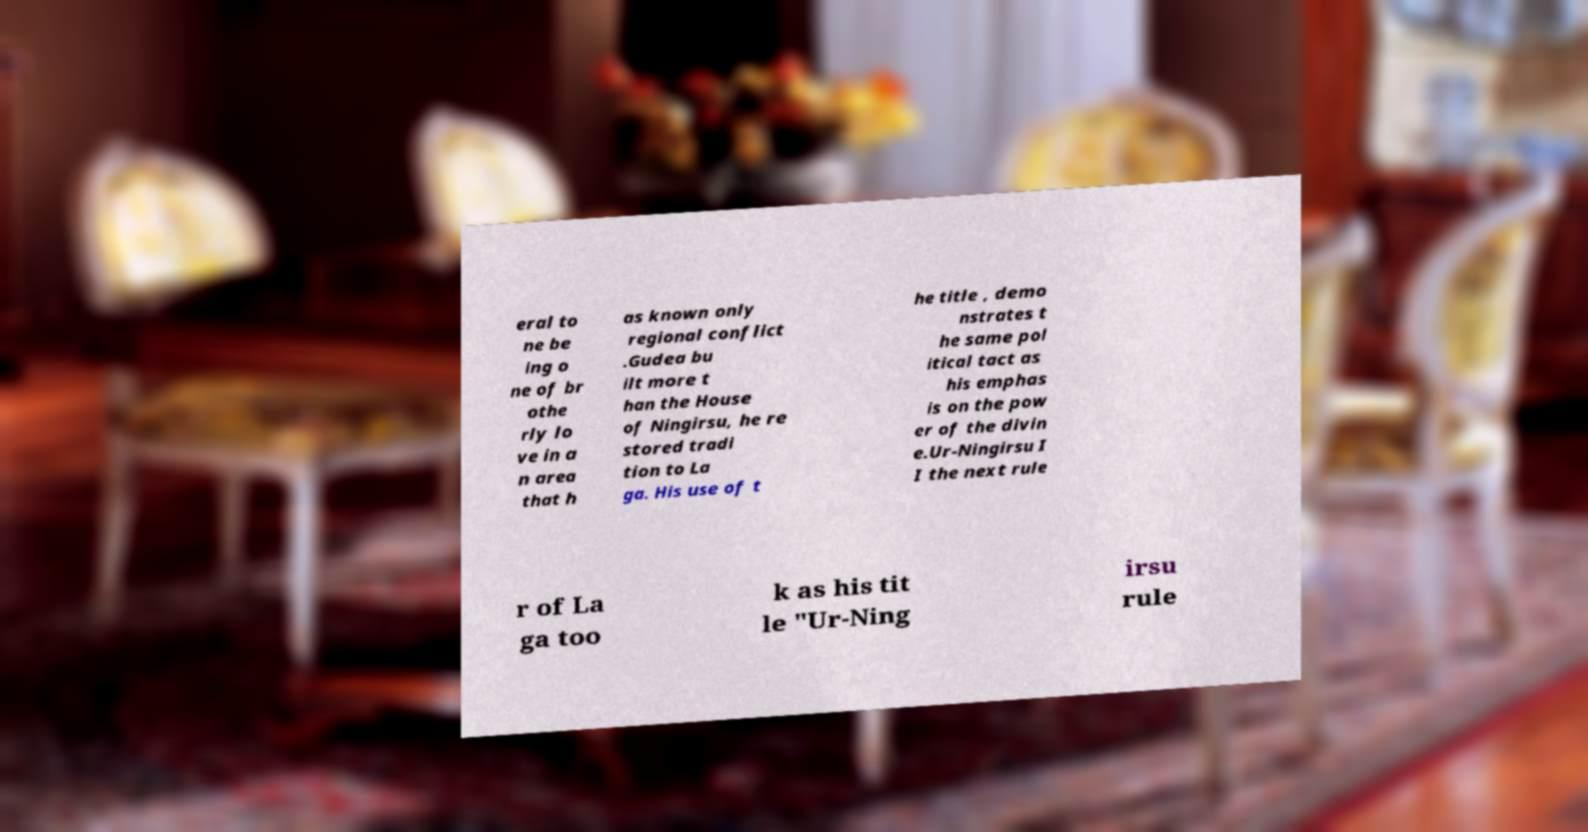I need the written content from this picture converted into text. Can you do that? eral to ne be ing o ne of br othe rly lo ve in a n area that h as known only regional conflict .Gudea bu ilt more t han the House of Ningirsu, he re stored tradi tion to La ga. His use of t he title , demo nstrates t he same pol itical tact as his emphas is on the pow er of the divin e.Ur-Ningirsu I I the next rule r of La ga too k as his tit le "Ur-Ning irsu rule 